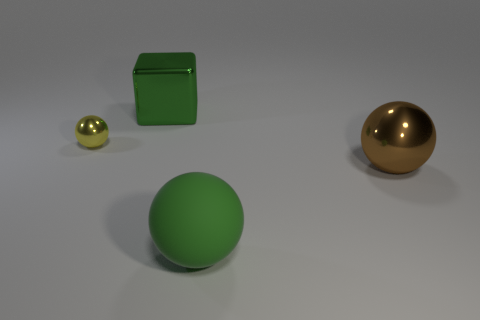Is there anything else that is the same shape as the big green metal object? The image displays three objects: a big green sphere, a smaller golden sphere, and a green cubic metal container. When comparing the shapes, there's a smaller object with a similar spherical shape to the big green one, which is the smaller golden sphere. 